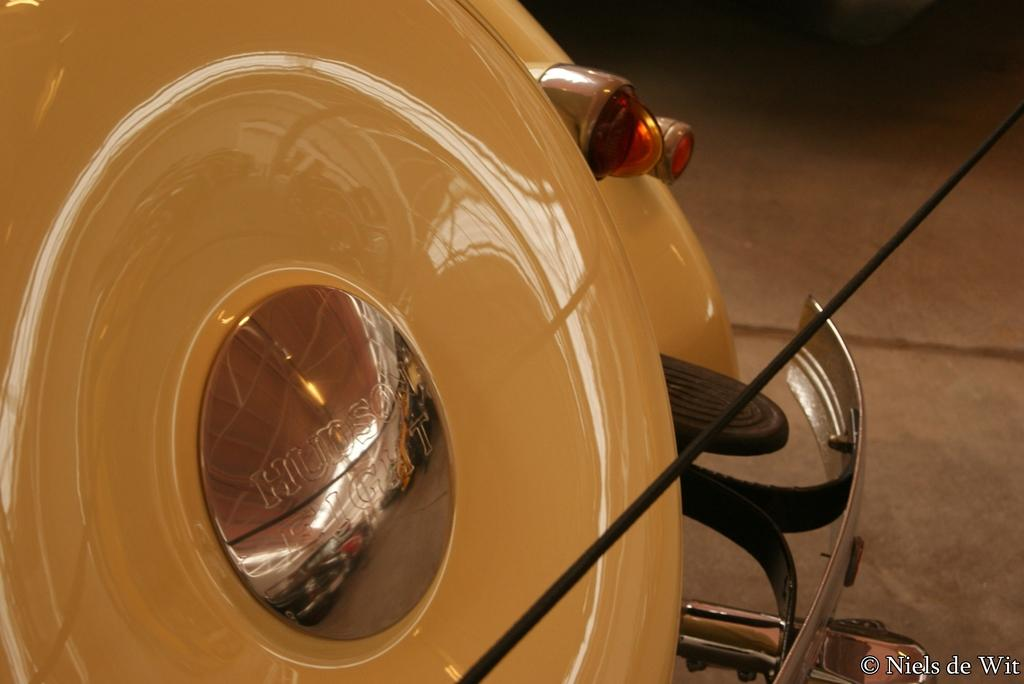What is the main subject of the image? The main subject of the image is a car. Can you describe any unique features or details about the car? Yes, there is a reflection of the interior of a shed on the car surface in the image. What type of experience does the car provide for its passengers? The image does not provide any information about the car's performance or passenger experience. 